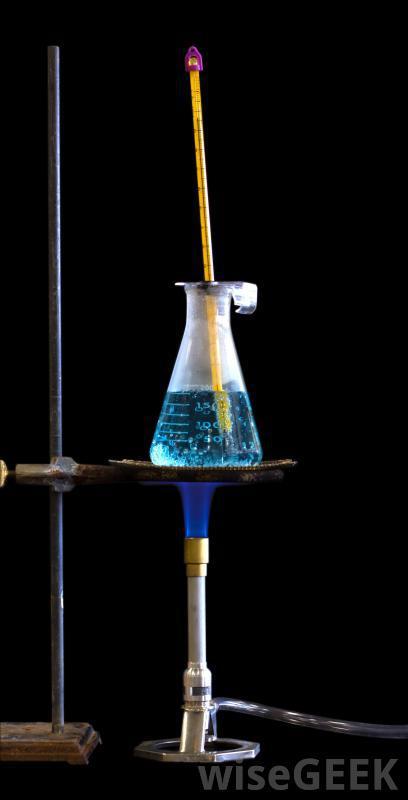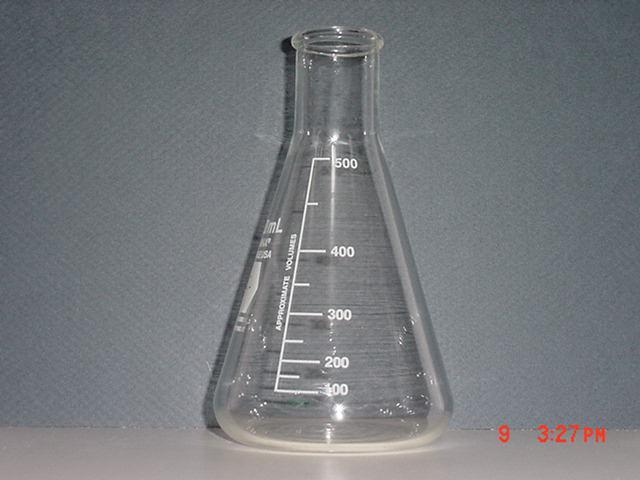The first image is the image on the left, the second image is the image on the right. Analyze the images presented: Is the assertion "There are two science beakers." valid? Answer yes or no. Yes. The first image is the image on the left, the second image is the image on the right. For the images displayed, is the sentence "There is one empty container in the left image." factually correct? Answer yes or no. No. 